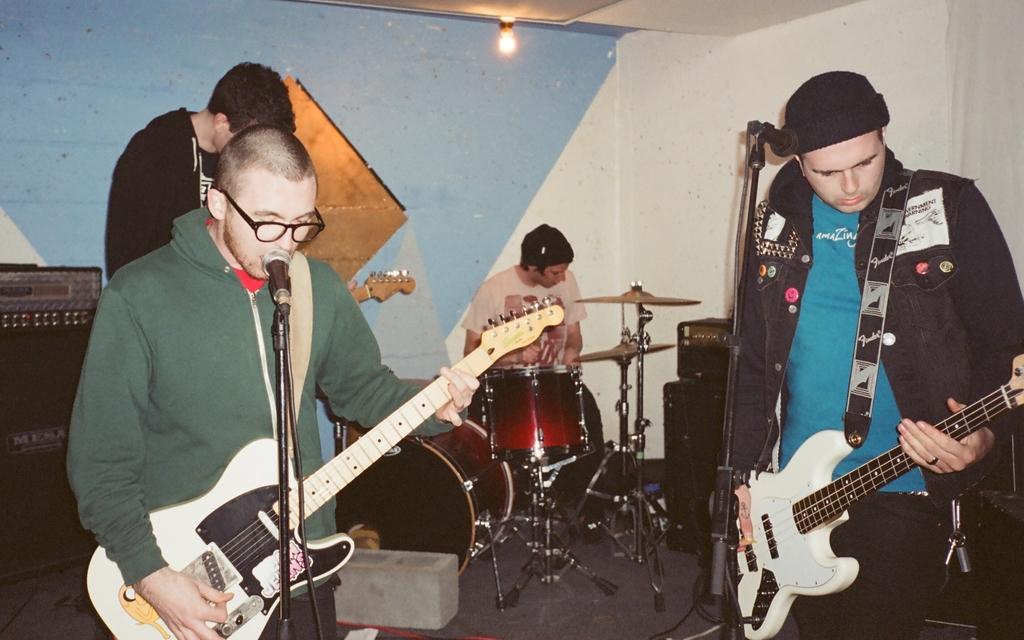Please provide a concise description of this image. In this image I can see four people where three of them are holding guitars and one is sitting next to a drum set. In the background I can see a light and a speaker. 